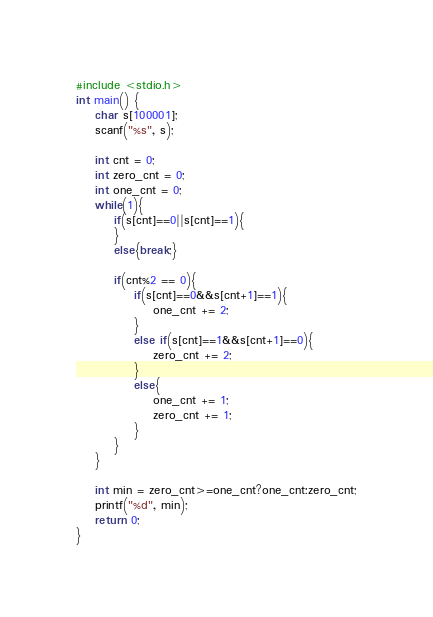Convert code to text. <code><loc_0><loc_0><loc_500><loc_500><_C_>#include <stdio.h>
int main() {
	char s[100001];
	scanf("%s", s);
	
	int cnt = 0;
	int zero_cnt = 0;
	int one_cnt = 0;
	while(1){
		if(s[cnt]==0||s[cnt]==1){
		}
		else{break;}
		
		if(cnt%2 == 0){
			if(s[cnt]==0&&s[cnt+1]==1){
				one_cnt += 2;
			}
			else if(s[cnt]==1&&s[cnt+1]==0){
				zero_cnt += 2;
			}
			else{
				one_cnt += 1;
				zero_cnt += 1;
			}
		}
	}
	
	int min = zero_cnt>=one_cnt?one_cnt:zero_cnt;
	printf("%d", min);
	return 0;
}</code> 